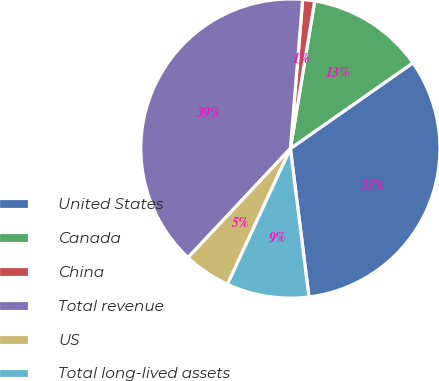<chart> <loc_0><loc_0><loc_500><loc_500><pie_chart><fcel>United States<fcel>Canada<fcel>China<fcel>Total revenue<fcel>US<fcel>Total long-lived assets<nl><fcel>32.73%<fcel>12.69%<fcel>1.29%<fcel>39.31%<fcel>5.09%<fcel>8.89%<nl></chart> 